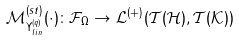Convert formula to latex. <formula><loc_0><loc_0><loc_500><loc_500>\mathcal { M } _ { \Upsilon _ { l i n } ^ { ( q ) } } ^ { ( s t ) } ( \cdot ) \colon \mathcal { F } _ { \Omega } \rightarrow \mathcal { L } ^ { ( + ) } \mathcal { ( T ( H ) } , \mathcal { T ( K ) ) }</formula> 